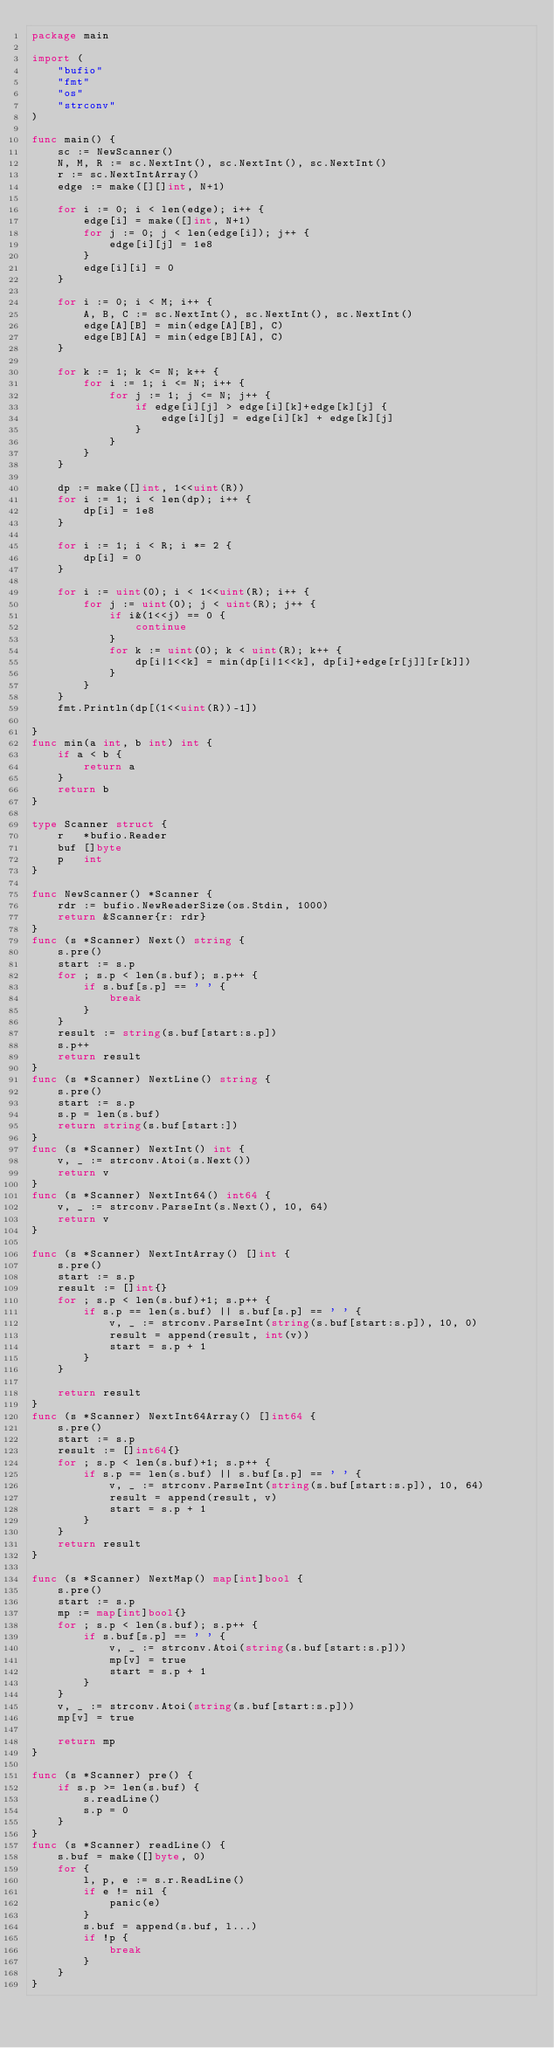<code> <loc_0><loc_0><loc_500><loc_500><_Go_>package main

import (
	"bufio"
	"fmt"
	"os"
	"strconv"
)

func main() {
	sc := NewScanner()
	N, M, R := sc.NextInt(), sc.NextInt(), sc.NextInt()
	r := sc.NextIntArray()
	edge := make([][]int, N+1)

	for i := 0; i < len(edge); i++ {
		edge[i] = make([]int, N+1)
		for j := 0; j < len(edge[i]); j++ {
			edge[i][j] = 1e8
		}
		edge[i][i] = 0
	}

	for i := 0; i < M; i++ {
		A, B, C := sc.NextInt(), sc.NextInt(), sc.NextInt()
		edge[A][B] = min(edge[A][B], C)
		edge[B][A] = min(edge[B][A], C)
	}

	for k := 1; k <= N; k++ {
		for i := 1; i <= N; i++ {
			for j := 1; j <= N; j++ {
				if edge[i][j] > edge[i][k]+edge[k][j] {
					edge[i][j] = edge[i][k] + edge[k][j]
				}
			}
		}
	}

	dp := make([]int, 1<<uint(R))
	for i := 1; i < len(dp); i++ {
		dp[i] = 1e8
	}

	for i := 1; i < R; i *= 2 {
		dp[i] = 0
	}

	for i := uint(0); i < 1<<uint(R); i++ {
		for j := uint(0); j < uint(R); j++ {
			if i&(1<<j) == 0 {
				continue
			}
			for k := uint(0); k < uint(R); k++ {
				dp[i|1<<k] = min(dp[i|1<<k], dp[i]+edge[r[j]][r[k]])
			}
		}
	}
	fmt.Println(dp[(1<<uint(R))-1])

}
func min(a int, b int) int {
	if a < b {
		return a
	}
	return b
}

type Scanner struct {
	r   *bufio.Reader
	buf []byte
	p   int
}

func NewScanner() *Scanner {
	rdr := bufio.NewReaderSize(os.Stdin, 1000)
	return &Scanner{r: rdr}
}
func (s *Scanner) Next() string {
	s.pre()
	start := s.p
	for ; s.p < len(s.buf); s.p++ {
		if s.buf[s.p] == ' ' {
			break
		}
	}
	result := string(s.buf[start:s.p])
	s.p++
	return result
}
func (s *Scanner) NextLine() string {
	s.pre()
	start := s.p
	s.p = len(s.buf)
	return string(s.buf[start:])
}
func (s *Scanner) NextInt() int {
	v, _ := strconv.Atoi(s.Next())
	return v
}
func (s *Scanner) NextInt64() int64 {
	v, _ := strconv.ParseInt(s.Next(), 10, 64)
	return v
}

func (s *Scanner) NextIntArray() []int {
	s.pre()
	start := s.p
	result := []int{}
	for ; s.p < len(s.buf)+1; s.p++ {
		if s.p == len(s.buf) || s.buf[s.p] == ' ' {
			v, _ := strconv.ParseInt(string(s.buf[start:s.p]), 10, 0)
			result = append(result, int(v))
			start = s.p + 1
		}
	}

	return result
}
func (s *Scanner) NextInt64Array() []int64 {
	s.pre()
	start := s.p
	result := []int64{}
	for ; s.p < len(s.buf)+1; s.p++ {
		if s.p == len(s.buf) || s.buf[s.p] == ' ' {
			v, _ := strconv.ParseInt(string(s.buf[start:s.p]), 10, 64)
			result = append(result, v)
			start = s.p + 1
		}
	}
	return result
}

func (s *Scanner) NextMap() map[int]bool {
	s.pre()
	start := s.p
	mp := map[int]bool{}
	for ; s.p < len(s.buf); s.p++ {
		if s.buf[s.p] == ' ' {
			v, _ := strconv.Atoi(string(s.buf[start:s.p]))
			mp[v] = true
			start = s.p + 1
		}
	}
	v, _ := strconv.Atoi(string(s.buf[start:s.p]))
	mp[v] = true

	return mp
}

func (s *Scanner) pre() {
	if s.p >= len(s.buf) {
		s.readLine()
		s.p = 0
	}
}
func (s *Scanner) readLine() {
	s.buf = make([]byte, 0)
	for {
		l, p, e := s.r.ReadLine()
		if e != nil {
			panic(e)
		}
		s.buf = append(s.buf, l...)
		if !p {
			break
		}
	}
}
</code> 